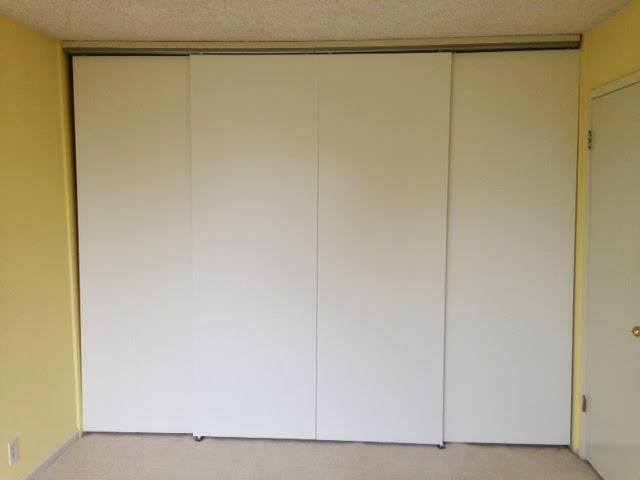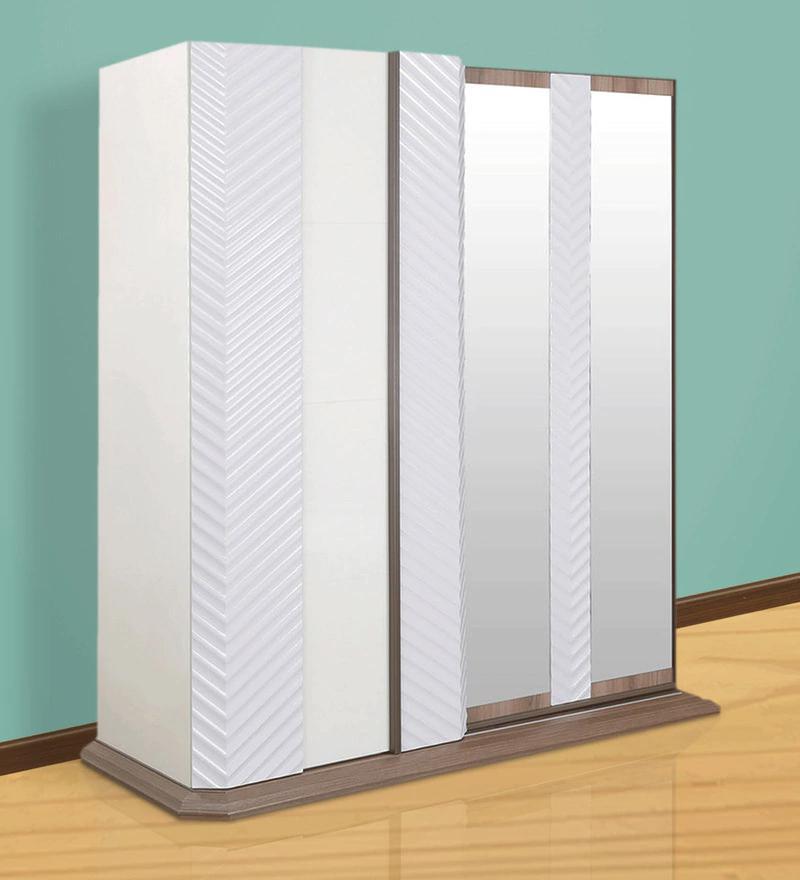The first image is the image on the left, the second image is the image on the right. Given the left and right images, does the statement "One design shows a door with a white center section and colored sections flanking it." hold true? Answer yes or no. No. The first image is the image on the left, the second image is the image on the right. Analyze the images presented: Is the assertion "there is a dark wooded floor in the image on the right" valid? Answer yes or no. No. 